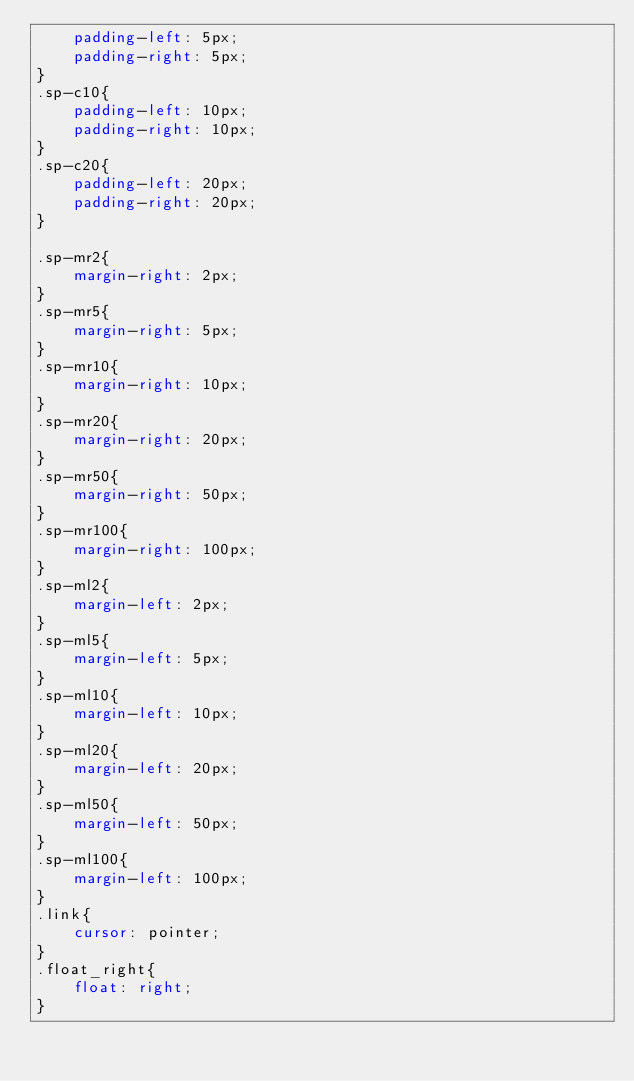Convert code to text. <code><loc_0><loc_0><loc_500><loc_500><_CSS_>    padding-left: 5px;
    padding-right: 5px;
}
.sp-c10{
    padding-left: 10px;
    padding-right: 10px;
}
.sp-c20{
    padding-left: 20px;
    padding-right: 20px;
}

.sp-mr2{
    margin-right: 2px;
}
.sp-mr5{
    margin-right: 5px;
}
.sp-mr10{
    margin-right: 10px;
}
.sp-mr20{
    margin-right: 20px;
}
.sp-mr50{
    margin-right: 50px;
}
.sp-mr100{
    margin-right: 100px;
}
.sp-ml2{
    margin-left: 2px;
}
.sp-ml5{
    margin-left: 5px;
}
.sp-ml10{
    margin-left: 10px;
}
.sp-ml20{
    margin-left: 20px;
}
.sp-ml50{
    margin-left: 50px;
}
.sp-ml100{
    margin-left: 100px;
}
.link{
    cursor: pointer;
}
.float_right{
    float: right;
}

</code> 